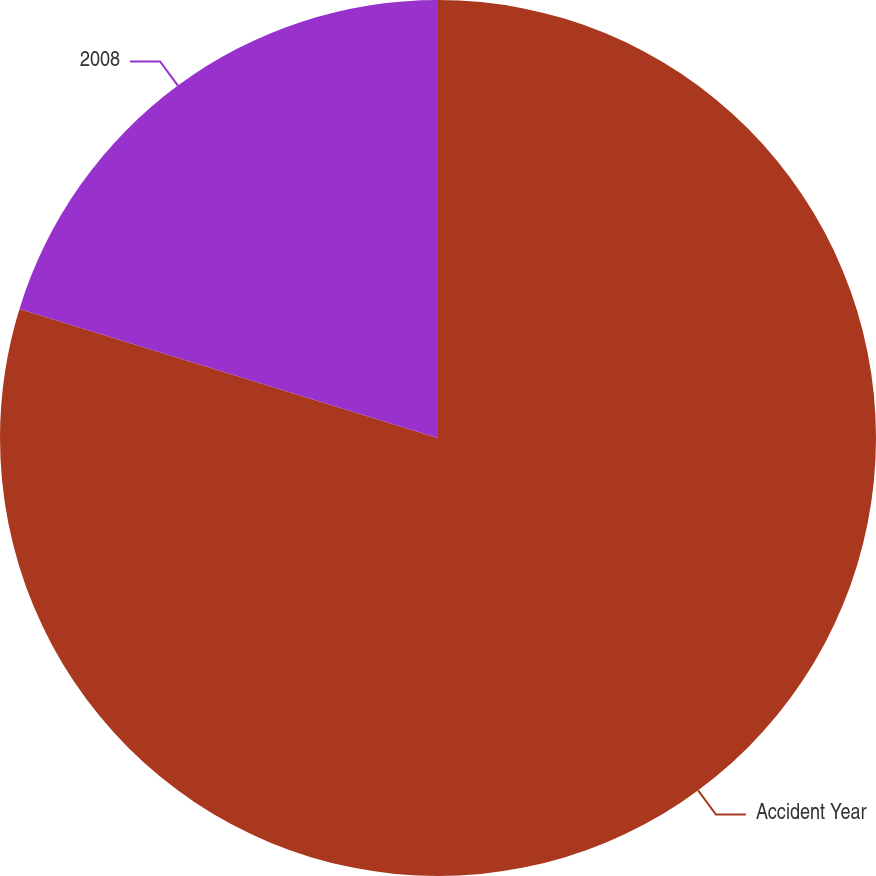Convert chart. <chart><loc_0><loc_0><loc_500><loc_500><pie_chart><fcel>Accident Year<fcel>2008<nl><fcel>79.76%<fcel>20.24%<nl></chart> 